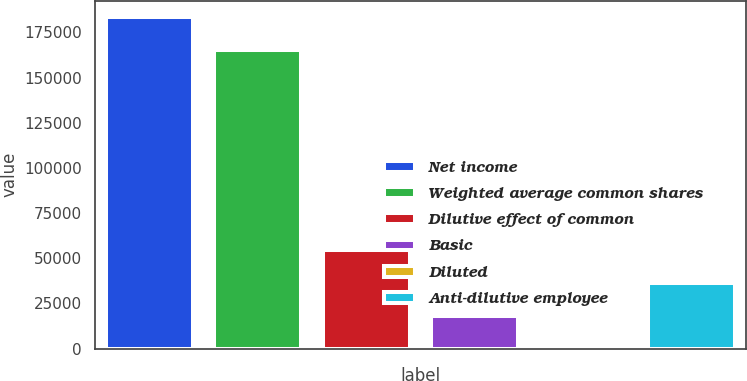Convert chart to OTSL. <chart><loc_0><loc_0><loc_500><loc_500><bar_chart><fcel>Net income<fcel>Weighted average common shares<fcel>Dilutive effect of common<fcel>Basic<fcel>Diluted<fcel>Anti-dilutive employee<nl><fcel>183367<fcel>165127<fcel>54721.4<fcel>18241.3<fcel>1.21<fcel>36481.4<nl></chart> 